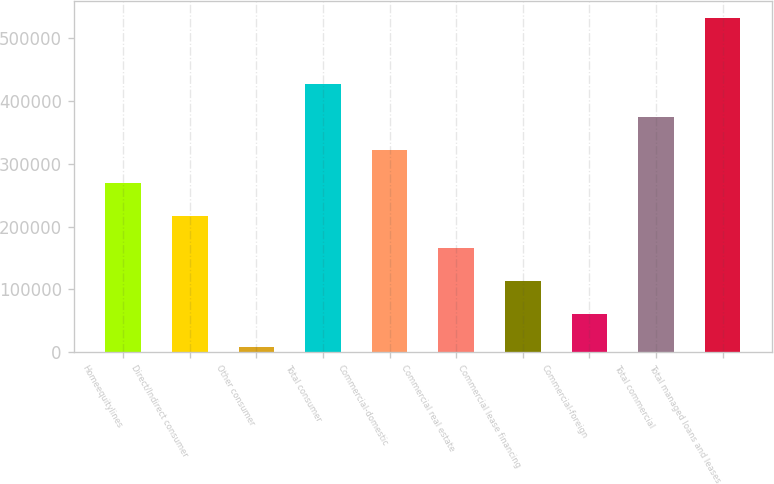Convert chart. <chart><loc_0><loc_0><loc_500><loc_500><bar_chart><fcel>Homeequitylines<fcel>Direct/Indirect consumer<fcel>Other consumer<fcel>Total consumer<fcel>Commercial-domestic<fcel>Commercial real estate<fcel>Commercial lease financing<fcel>Commercial-foreign<fcel>Total commercial<fcel>Total managed loans and leases<nl><fcel>270061<fcel>217537<fcel>7439<fcel>427634<fcel>322585<fcel>165012<fcel>112488<fcel>59963.4<fcel>375110<fcel>532683<nl></chart> 